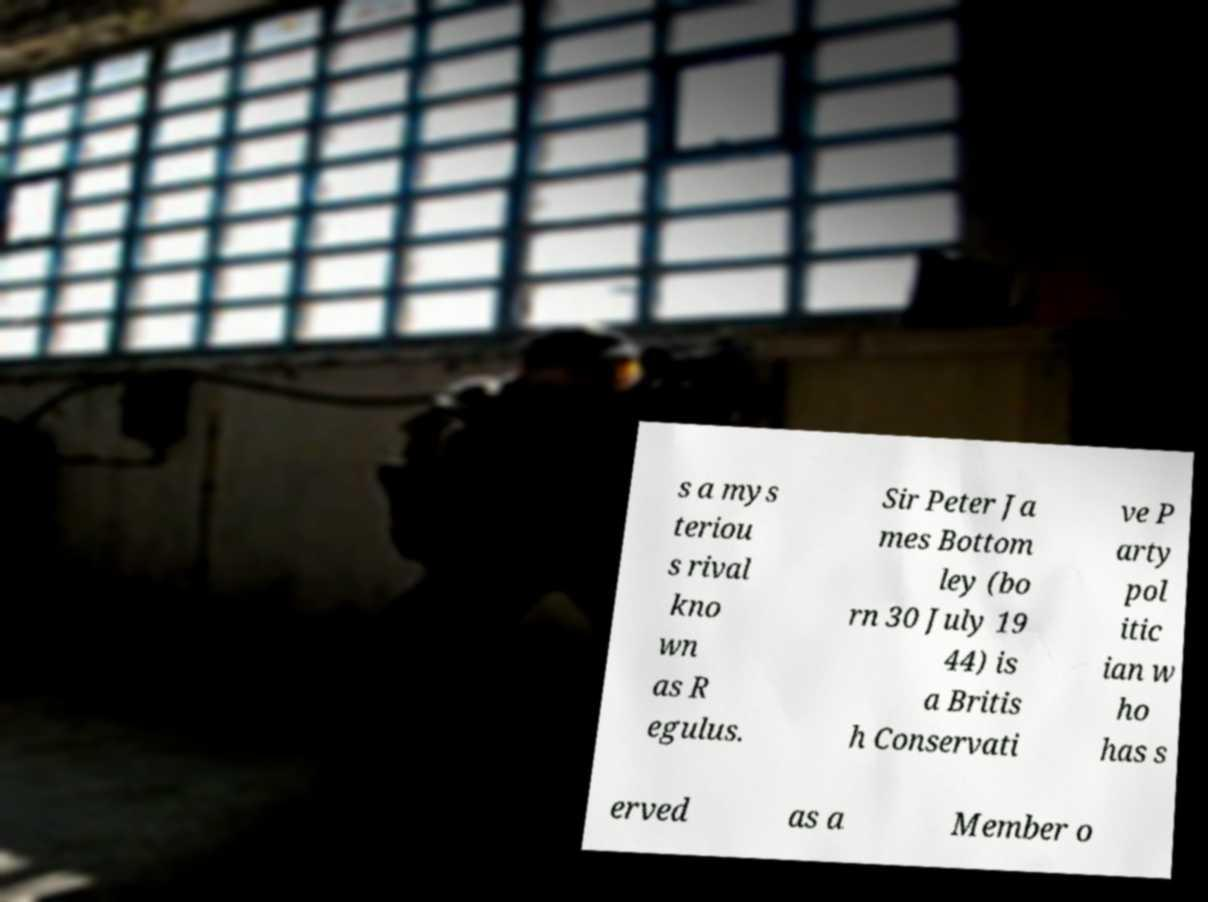There's text embedded in this image that I need extracted. Can you transcribe it verbatim? s a mys teriou s rival kno wn as R egulus. Sir Peter Ja mes Bottom ley (bo rn 30 July 19 44) is a Britis h Conservati ve P arty pol itic ian w ho has s erved as a Member o 